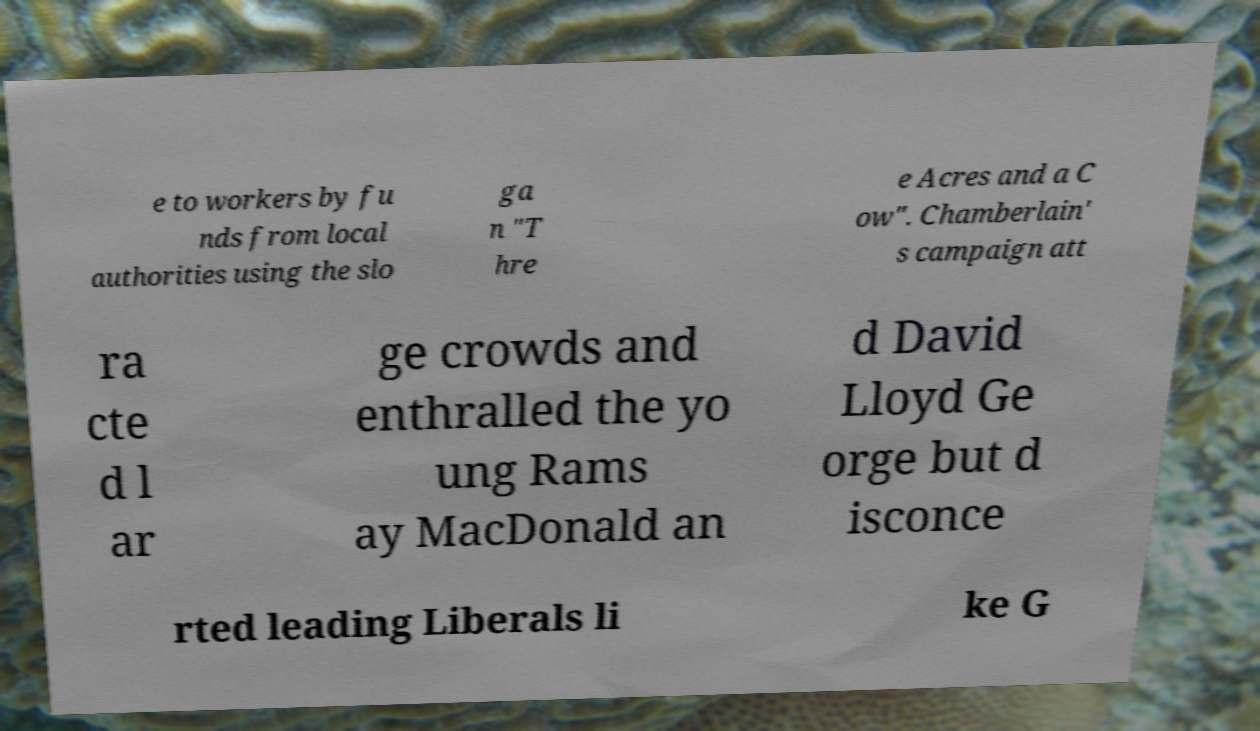For documentation purposes, I need the text within this image transcribed. Could you provide that? e to workers by fu nds from local authorities using the slo ga n "T hre e Acres and a C ow". Chamberlain' s campaign att ra cte d l ar ge crowds and enthralled the yo ung Rams ay MacDonald an d David Lloyd Ge orge but d isconce rted leading Liberals li ke G 